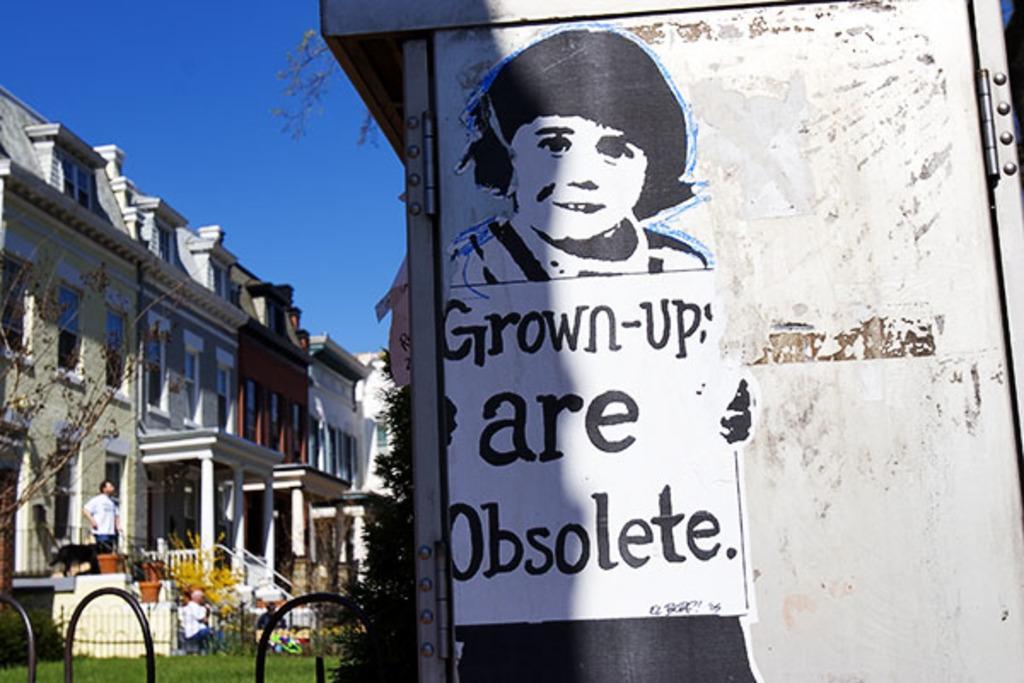Describe this image in one or two sentences. In this picture we can see a poster on the iron object and on the left side of the poster there is the fence, trees, a person is standing and other people are sitting. Behind the people there are buildings and the sky. 